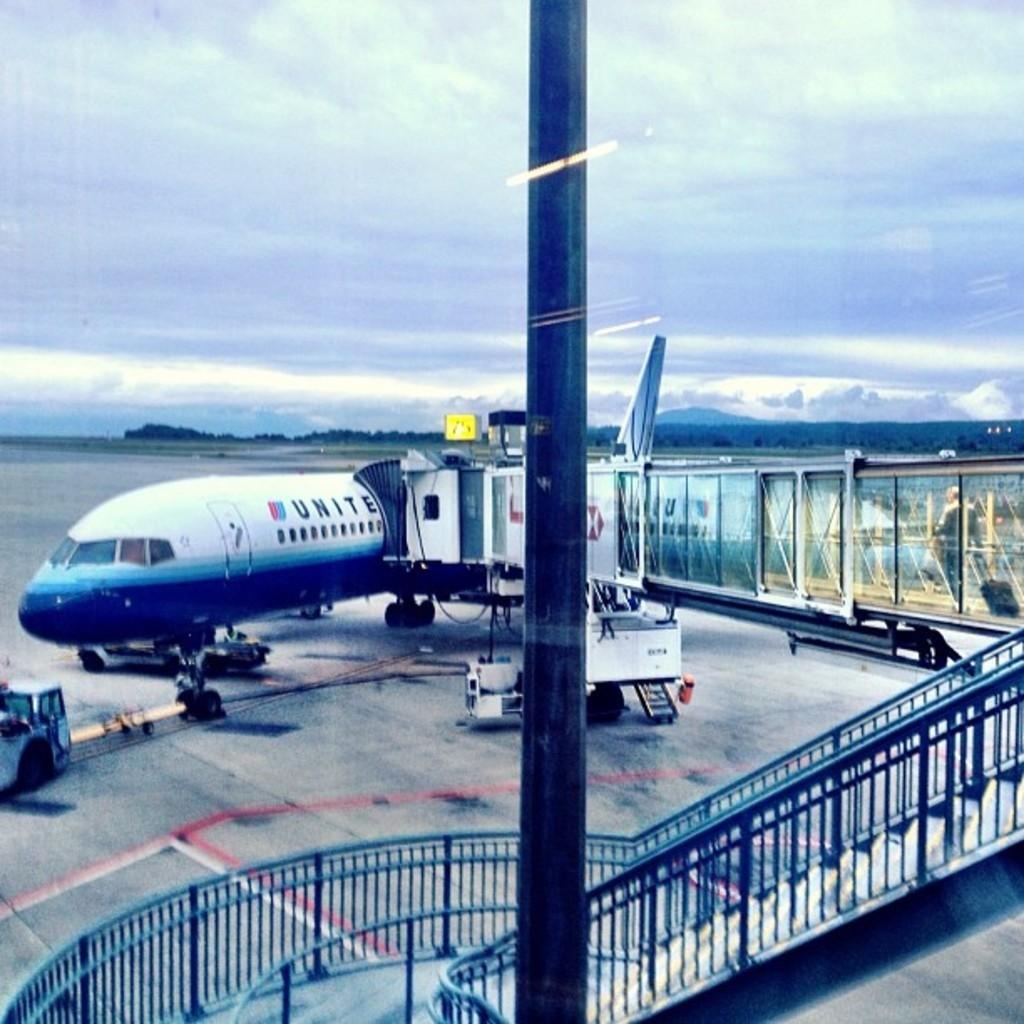What is the main subject of the image? The main subject of the image is a flight. What other objects can be seen in the image? There is a pole and a fence visible in the image. What is visible at the top of the image? The sky is visible at the top of the image. What type of orange can be seen growing in the field in the image? There is no orange or field present in the image; it features a flight and other objects. 